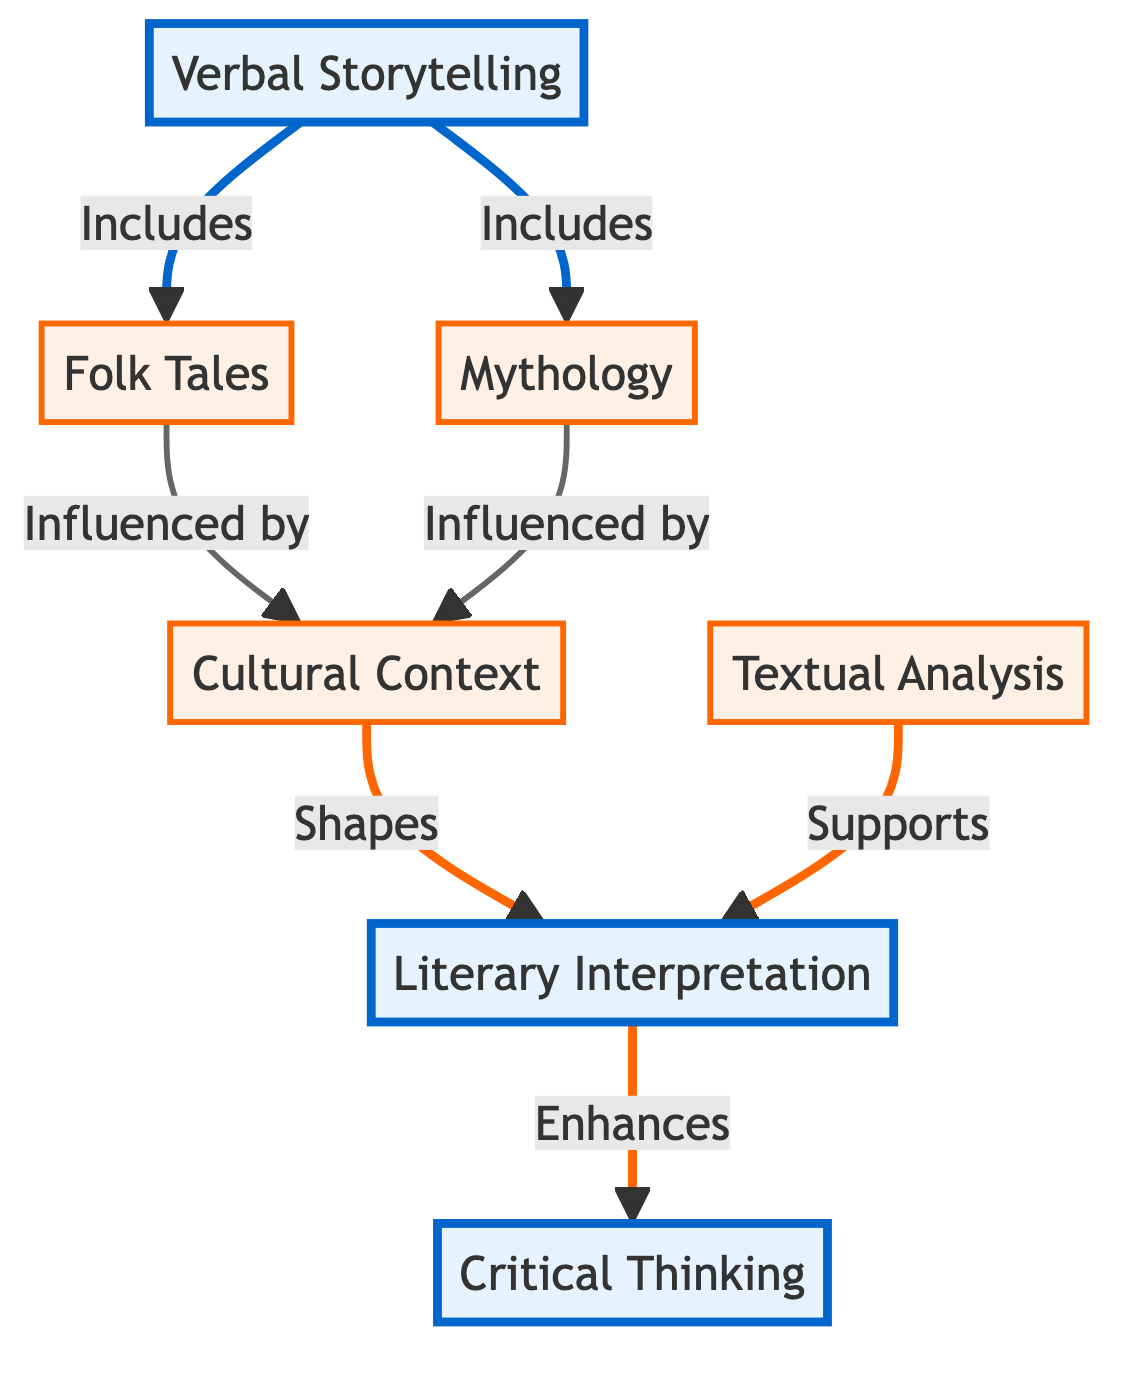What are the two main components listed in the diagram? The diagram includes "Verbal Storytelling" and "Literary Interpretation" as the main components, indicated by the distinctive styling showing they are primary nodes.
Answer: Verbal Storytelling, Literary Interpretation How many secondary nodes are there in the diagram? Counting the nodes labeled as secondary, there are four: "Folk Tales", "Mythology", "Cultural Context", and "Textual Analysis." Therefore, the total number is four.
Answer: Four What does "Cultural Context" shape according to the diagram? "Cultural Context" is shown to shape "Literary Interpretation," as indicated by the arrow connecting the two nodes, suggesting a directional influence.
Answer: Literary Interpretation What relationship does "Textual Analysis" have with "Literary Interpretation"? The relationship is that "Textual Analysis" supports "Literary Interpretation," as shown by the arrow pointing from the former to the latter.
Answer: Supports Which node enhances "Critical Thinking"? The node that enhances "Critical Thinking" is "Literary Interpretation," as the diagram illustrates a direct connection with an arrow leading to "Critical Thinking."
Answer: Literary Interpretation How are "Folk Tales" and "Mythology" related to "Cultural Context"? Both "Folk Tales" and "Mythology" are influenced by "Cultural Context," illustrated by the arrows pointing from each of these nodes to "Cultural Context," indicating a directional relationship of influence.
Answer: Influenced by What is the main function of "Verbal Storytelling" in this diagram? The main function of "Verbal Storytelling" is to include "Folk Tales" and "Mythology," as seen from the connecting arrows illustrating that it serves as an encompassing category for both.
Answer: Includes What color coding is used for the main nodes in the diagram? The main nodes are colored in a light blue shade, distinctly different from the orange hue used for the secondary nodes, indicating their primary importance.
Answer: Light blue 